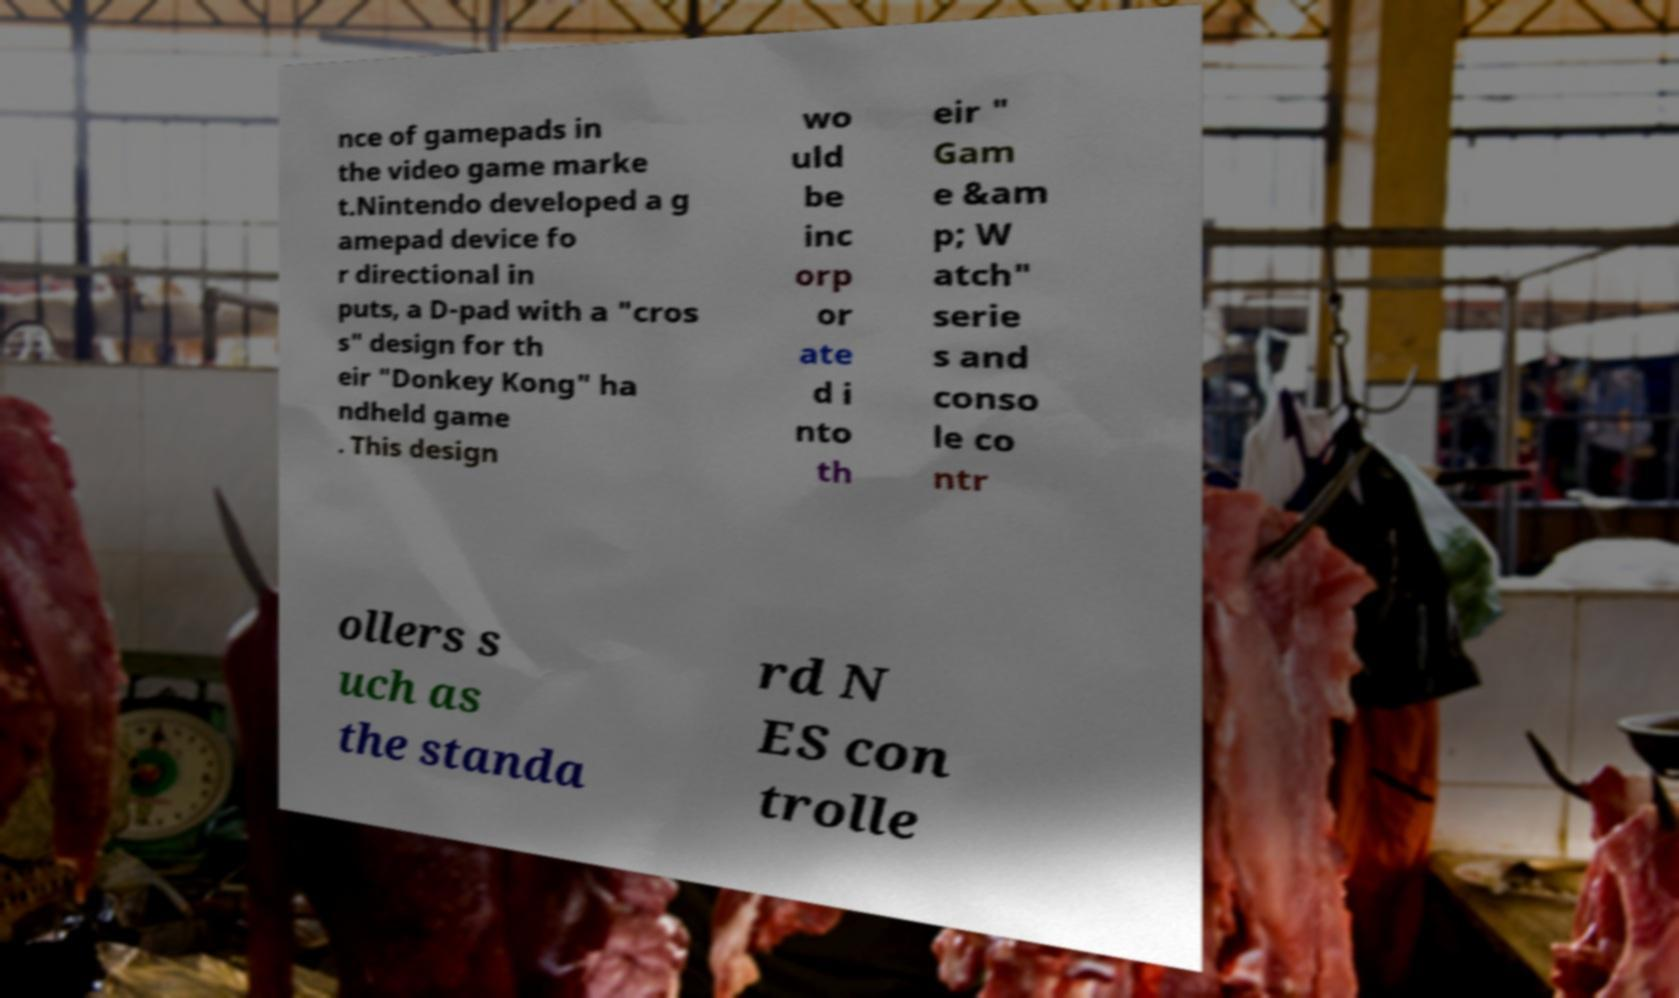Can you accurately transcribe the text from the provided image for me? nce of gamepads in the video game marke t.Nintendo developed a g amepad device fo r directional in puts, a D-pad with a "cros s" design for th eir "Donkey Kong" ha ndheld game . This design wo uld be inc orp or ate d i nto th eir " Gam e &am p; W atch" serie s and conso le co ntr ollers s uch as the standa rd N ES con trolle 